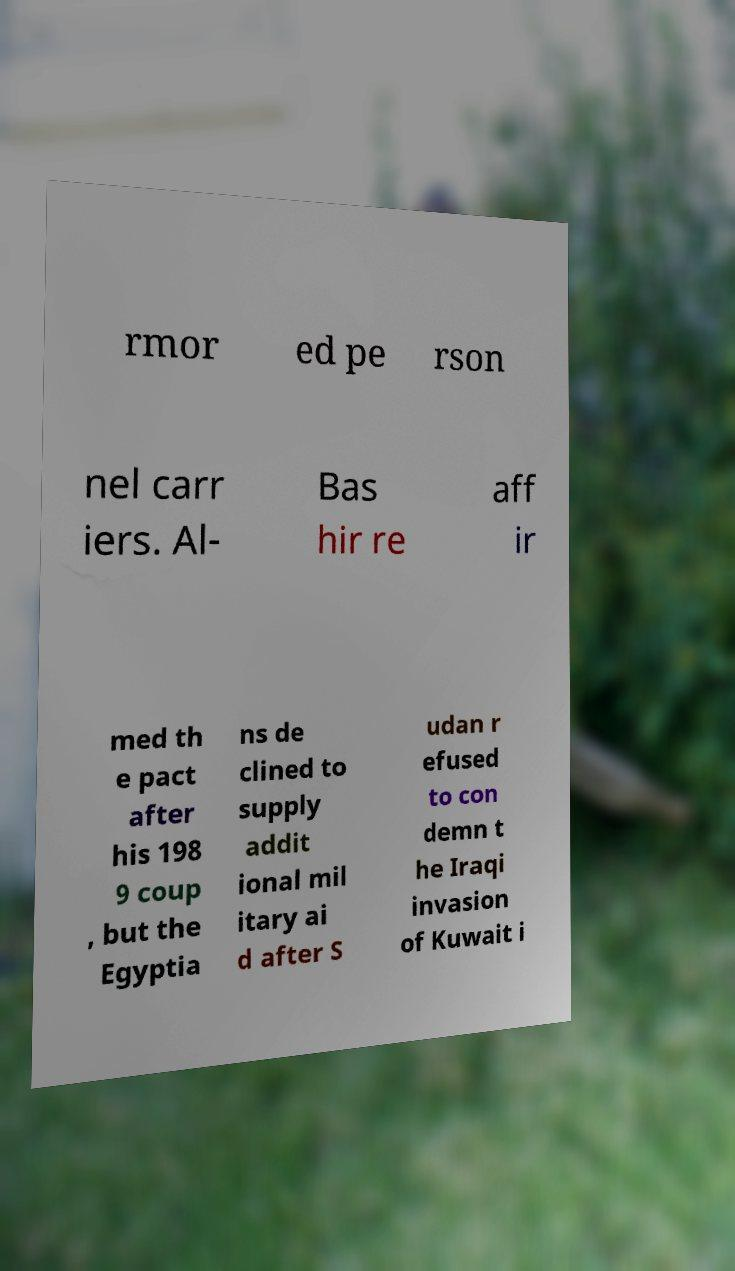Please read and relay the text visible in this image. What does it say? rmor ed pe rson nel carr iers. Al- Bas hir re aff ir med th e pact after his 198 9 coup , but the Egyptia ns de clined to supply addit ional mil itary ai d after S udan r efused to con demn t he Iraqi invasion of Kuwait i 